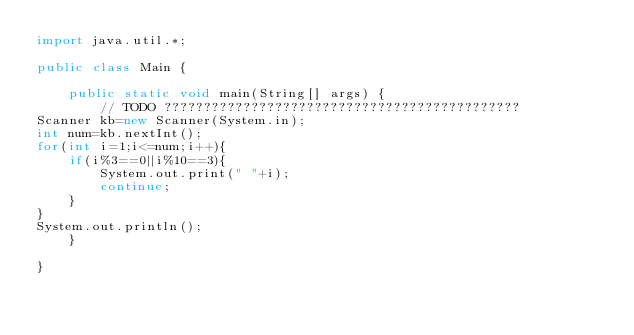<code> <loc_0><loc_0><loc_500><loc_500><_Java_>import java.util.*;

public class Main {

	public static void main(String[] args) {
		// TODO ?????????????????????????????????????????????
Scanner kb=new Scanner(System.in);
int num=kb.nextInt();
for(int i=1;i<=num;i++){
	if(i%3==0||i%10==3){
		System.out.print(" "+i);
		continue;
	}	
}
System.out.println();
	}

}</code> 